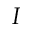<formula> <loc_0><loc_0><loc_500><loc_500>I</formula> 